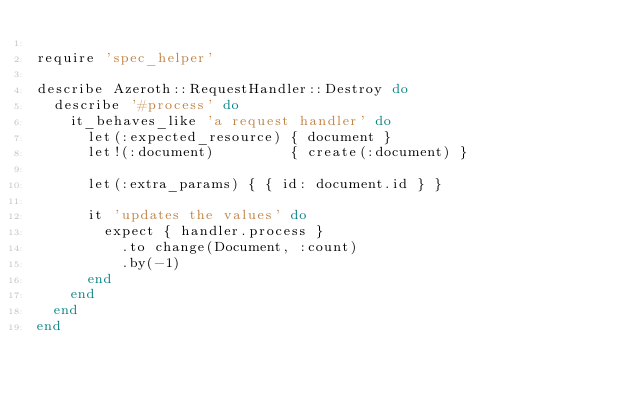Convert code to text. <code><loc_0><loc_0><loc_500><loc_500><_Ruby_>
require 'spec_helper'

describe Azeroth::RequestHandler::Destroy do
  describe '#process' do
    it_behaves_like 'a request handler' do
      let(:expected_resource) { document }
      let!(:document)         { create(:document) }

      let(:extra_params) { { id: document.id } }

      it 'updates the values' do
        expect { handler.process }
          .to change(Document, :count)
          .by(-1)
      end
    end
  end
end
</code> 